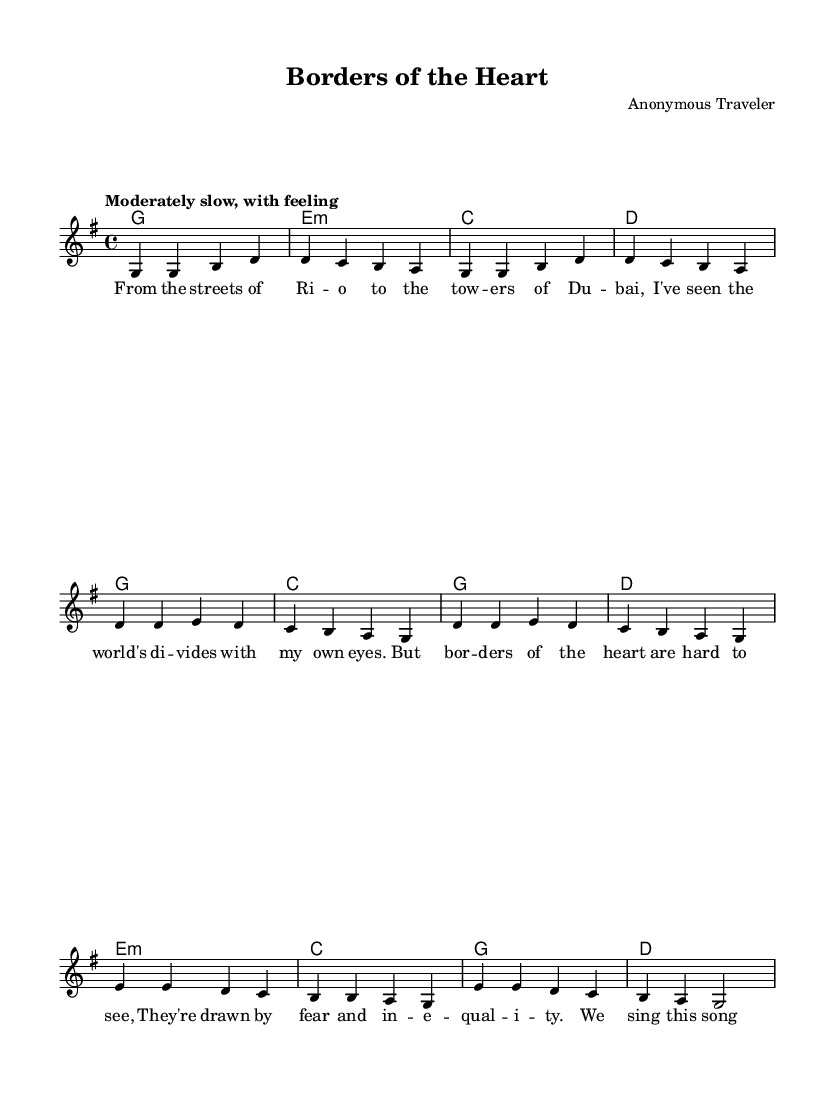What is the key signature of this music? The key signature is G major, which has one sharp (F#). This can be identified by looking at the key signature section at the beginning of the score.
Answer: G major What is the time signature of this music? The time signature is 4/4, which is indicated at the beginning of the score. A 4/4 time signature means there are four beats in each measure, and the quarter note gets one beat.
Answer: 4/4 What is the tempo of the piece? The tempo marking is "Moderately slow, with feeling," which provides guidance on the speed and style of performance. This is located in the tempo section at the beginning of the score.
Answer: Moderately slow, with feeling How many measures are there in the verse section? The verse section consists of 4 measures, which can be counted by identifying the separate musical phrases in the score that are divided into measures.
Answer: 4 measures What do the lyrics of the bridge suggest about the theme? The lyrics of the bridge, "We sing this song in every tongue, For justice that's too long unsung," indicate a theme of inclusivity and the call for social justice. This can be inferred by analyzing the content and meaning of the lyrics presented in the section.
Answer: Inclusivity and justice What is the structure of the song? The structure of the song follows a Verse-Chorus-Bridge pattern, commonly used in folk music. This can be identified by examining the order of musical sections and their labeling in the score.
Answer: Verse-Chorus-Bridge What social issues are addressed in the song's lyrics? The song addresses themes of division and inequality, as indicated in the lyrics, particularly in the chorus, which mentions draws by fear and inequality. This can be concluded by interpreting the messages conveyed in the lyrics throughout the piece.
Answer: Division and inequality 